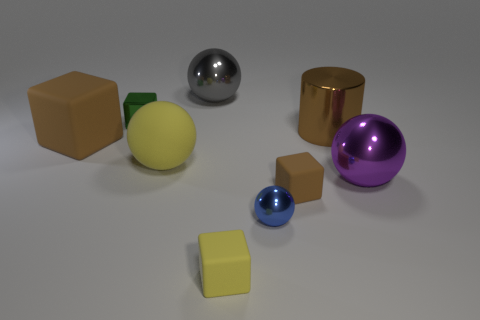How would you describe the lighting in this scene? The lighting in the scene is soft and diffuse, with what appears to be a single light source generating slight shadows directly underneath the objects, adding a sense of depth and dimension to the arrangement. 